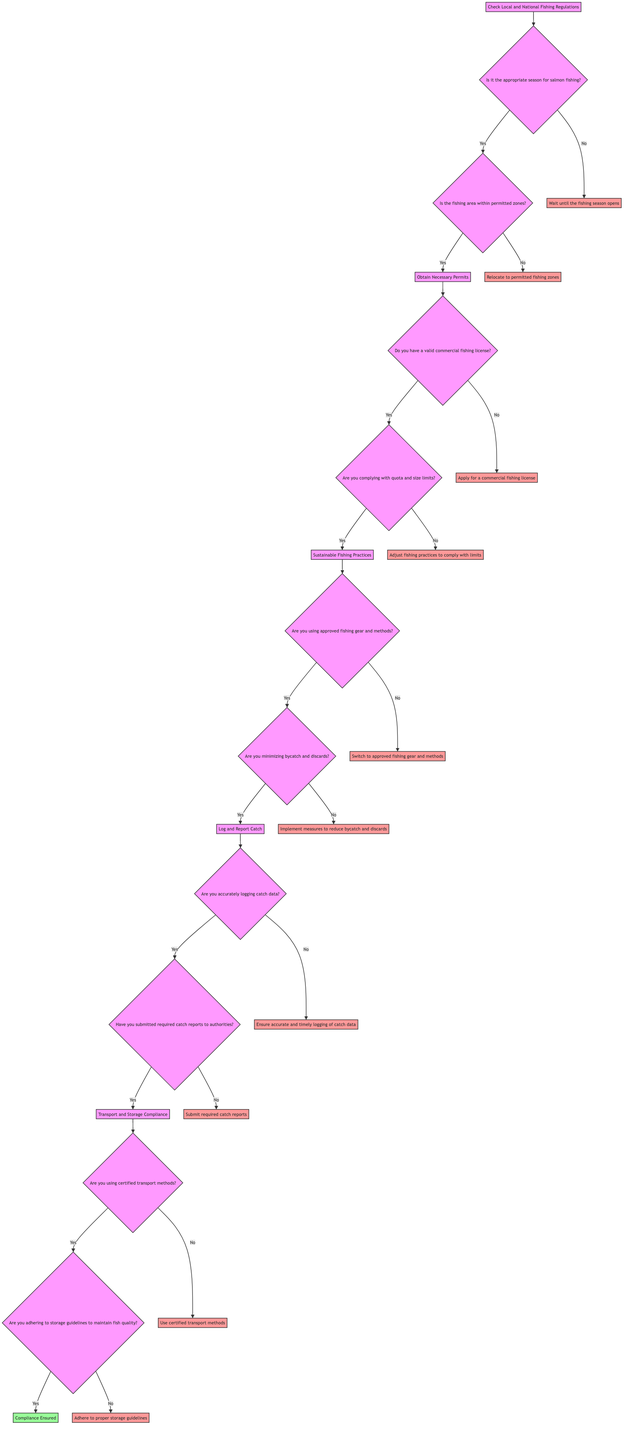What is the first step in the decision tree? The first step listed in the decision tree is "Check Local and National Fishing Regulations." This is the starting point before any other actions can be taken.
Answer: Check Local and National Fishing Regulations How many steps are there in total? The diagram outlines five distinct steps. They are sequential stages that ensure compliance with fishing regulations and environmental standards.
Answer: Five What happens if it's not the appropriate season for salmon fishing? If it is not the appropriate season for salmon fishing, the flow chart indicates that you should "Wait until the fishing season opens." This response becomes necessary before proceeding further.
Answer: Wait until the fishing season opens What is the required action if you do not have a valid commercial fishing license? If you do not have a valid commercial fishing license, the diagram specifies that you need to "Apply for a commercial fishing license" to continue complying with regulations.
Answer: Apply for a commercial fishing license What does the flow lead to after minimizing bycatch and discards? After confirming that you are minimizing bycatch and discards, the diagram leads to Step 4, which is "Log and Report Catch." This indicates readiness to move forward with reporting.
Answer: Log and Report Catch What if you are not adhering to storage guidelines? If you are not adhering to storage guidelines to maintain fish quality, the diagram advises that you should "Adhere to proper storage guidelines" to ensure compliance.
Answer: Adhere to proper storage guidelines What step follows obtaining necessary permits? After obtaining necessary permits, the next step in the diagram is "Sustainable Fishing Practices," marking a transition to ensuring environmentally friendly fishing methods.
Answer: Sustainable Fishing Practices How do you ensure compliance if you are not using certified transport methods? If you are not using certified transport methods, the flow chart indicates that you must "Use certified transport methods" to ensure compliance during the transportation phase.
Answer: Use certified transport methods 